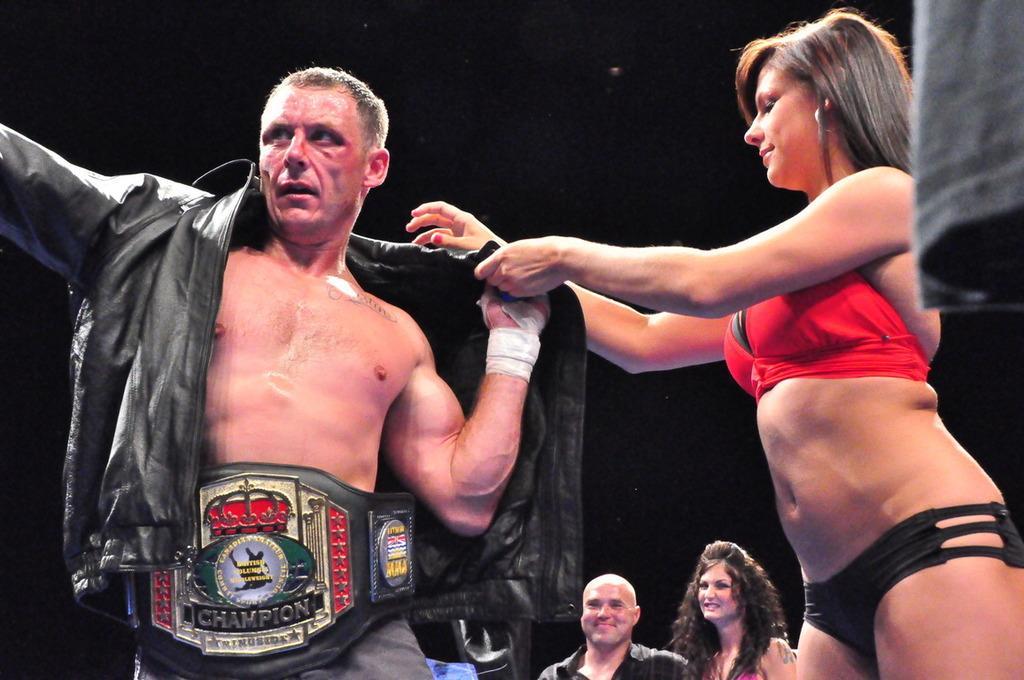How would you summarize this image in a sentence or two? Background portion of the picture is dark. We can see a woman and a man. In this picture we can see a woman holding a jacket with her hands and beside to her we can see a man wearing a champion belt. 